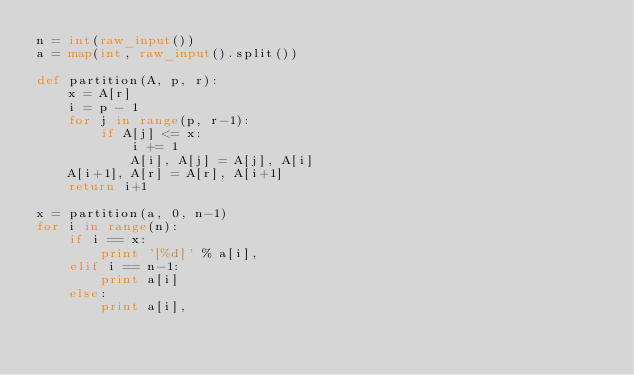Convert code to text. <code><loc_0><loc_0><loc_500><loc_500><_Python_>n = int(raw_input())
a = map(int, raw_input().split())

def partition(A, p, r):
    x = A[r]
    i = p - 1
    for j in range(p, r-1):
        if A[j] <= x:
            i += 1
            A[i], A[j] = A[j], A[i]
    A[i+1], A[r] = A[r], A[i+1]
    return i+1

x = partition(a, 0, n-1)
for i in range(n):
    if i == x:
        print '[%d]' % a[i],
    elif i == n-1:
        print a[i]
    else:
        print a[i],
            </code> 